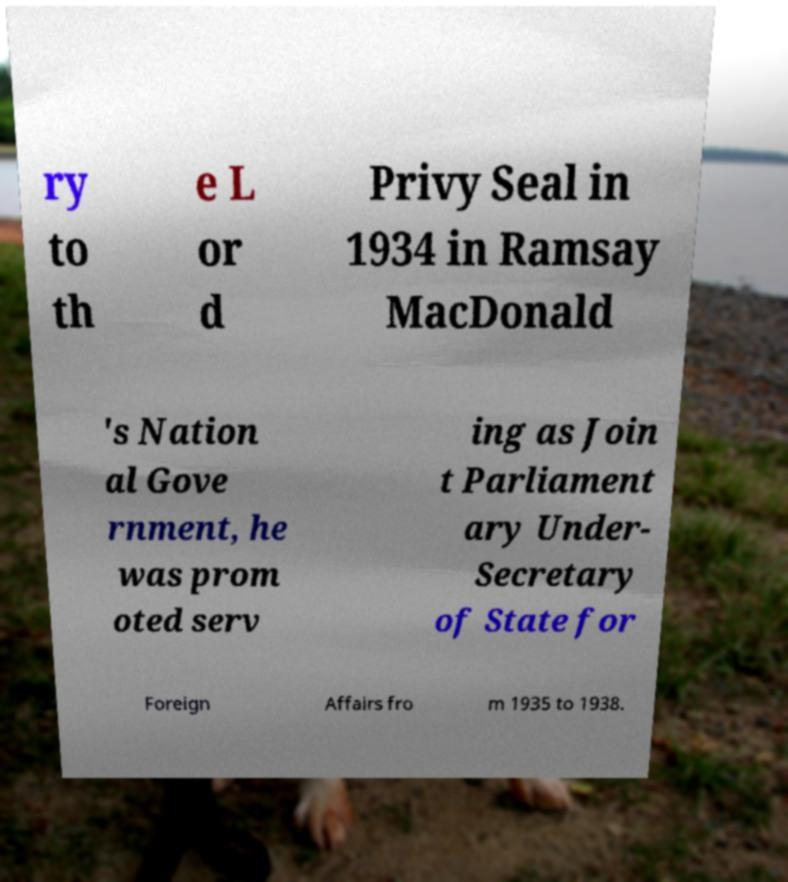What messages or text are displayed in this image? I need them in a readable, typed format. ry to th e L or d Privy Seal in 1934 in Ramsay MacDonald 's Nation al Gove rnment, he was prom oted serv ing as Join t Parliament ary Under- Secretary of State for Foreign Affairs fro m 1935 to 1938. 